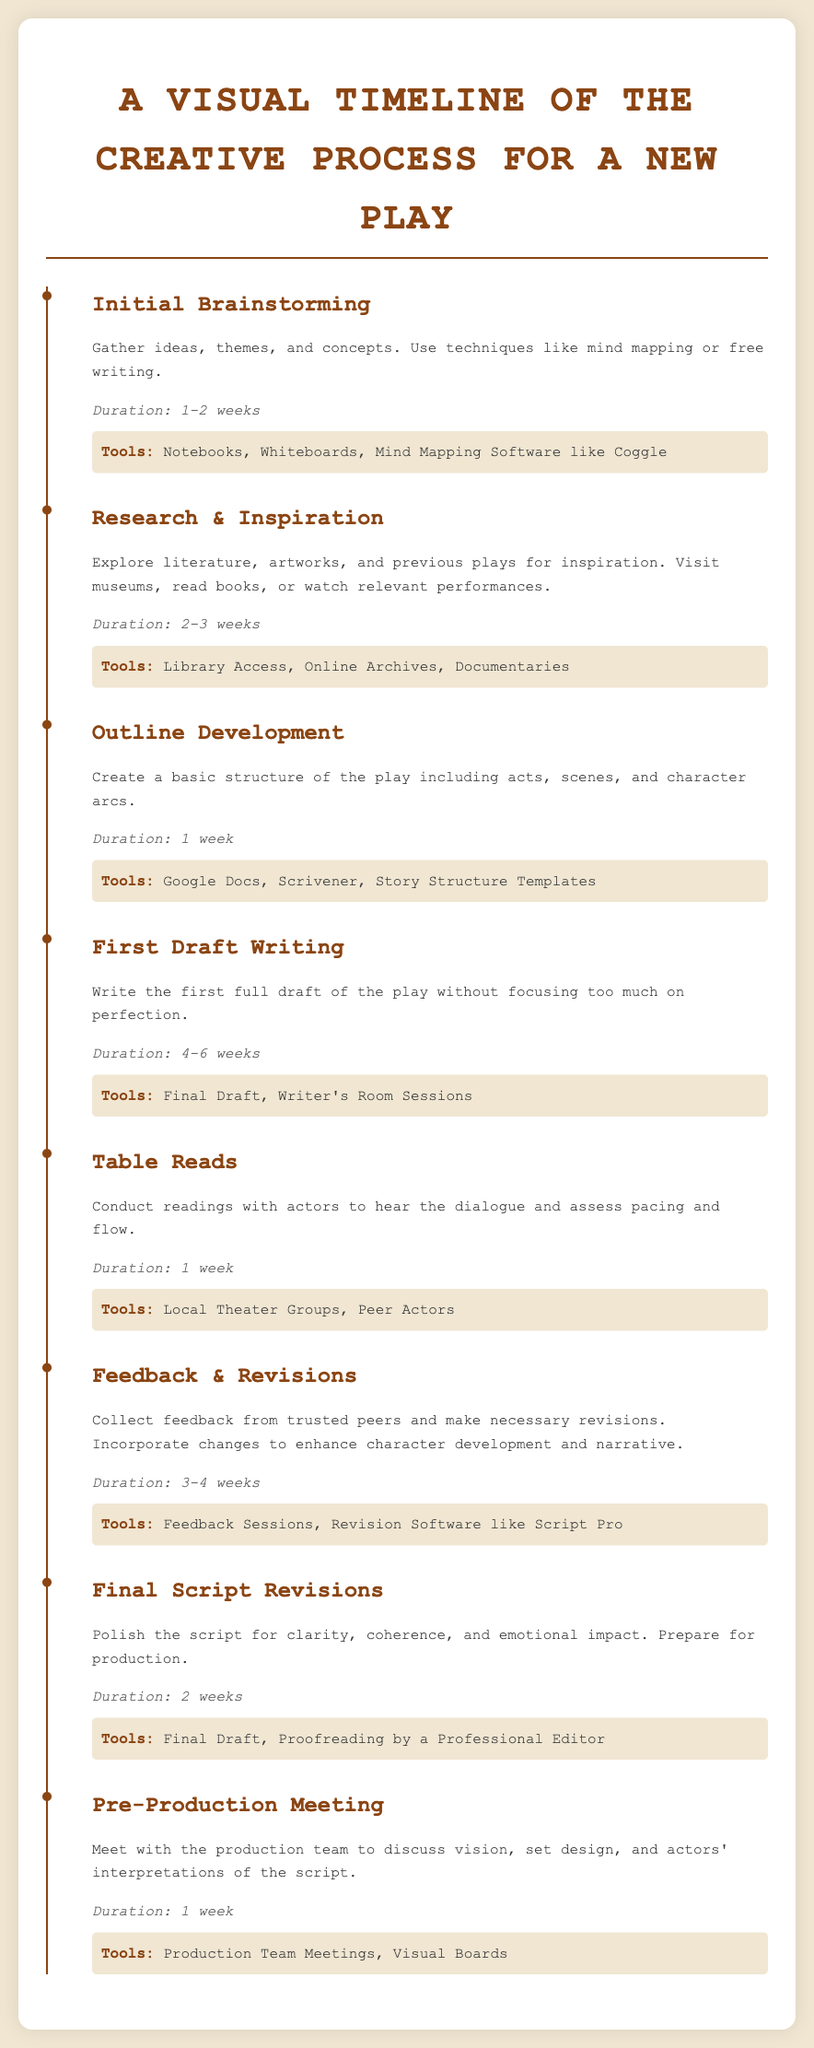What is the duration of the initial brainstorming stage? The duration of the initial brainstorming stage is clearly stated in the document as 1-2 weeks.
Answer: 1-2 weeks What is the main purpose of the research and inspiration stage? The document describes this stage as exploring literature, artworks, and previous plays for inspiration.
Answer: Explore literature, artworks, and previous plays How long is the feedback and revisions stage? The duration for the feedback and revisions stage is mentioned in the document as 3-4 weeks.
Answer: 3-4 weeks Which tool is suggested for writing the first draft? The document lists Final Draft as one of the tools for writing the first draft.
Answer: Final Draft What is the final outcome of the final script revisions stage? The document states that the final script revisions stage is to polish the script for clarity, coherence, and emotional impact.
Answer: Polish the script for clarity, coherence, and emotional impact How many stages are there in the creative process timeline? The document outlines seven distinct stages in the creative process for a new play.
Answer: Seven What is the last stage before production? According to the document, the last stage before production is the pre-production meeting.
Answer: Pre-Production Meeting What tool is recommended for outlining development? The document specifies using Google Docs as a tool for outline development.
Answer: Google Docs 